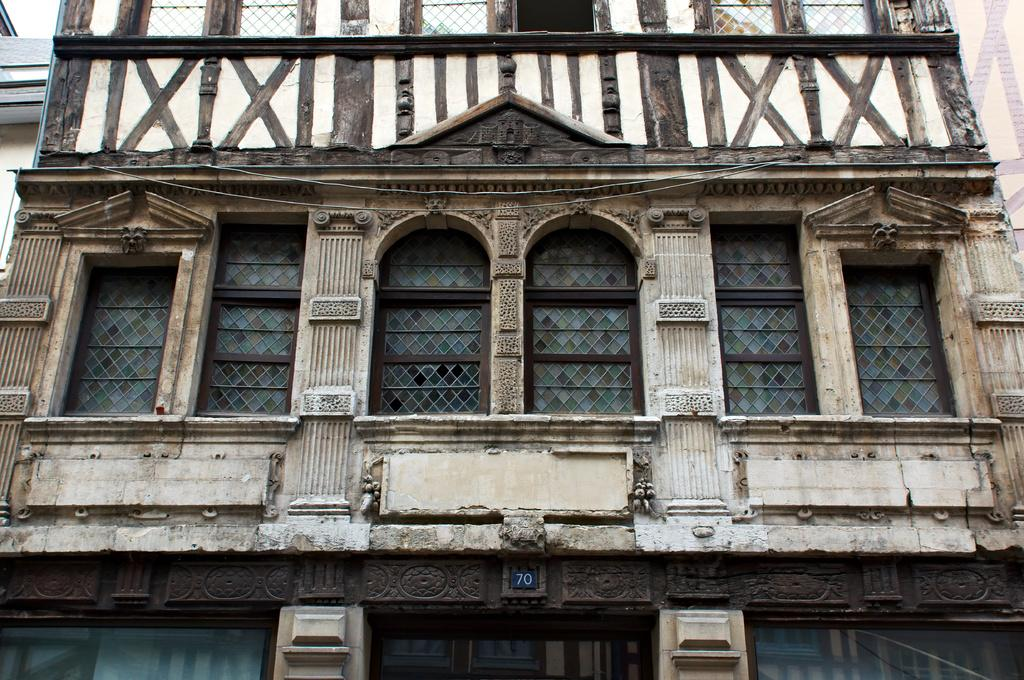What type of structure is visible in the image? There is a building in the image. What architectural features can be seen on the building? There are windows and a door visible in the image. What material is used for the walls of the building? Wallboard is present in the image. What type of pear is hanging from the door in the image? There is no pear present in the image; it features a building with windows, wallboard, and a door. 